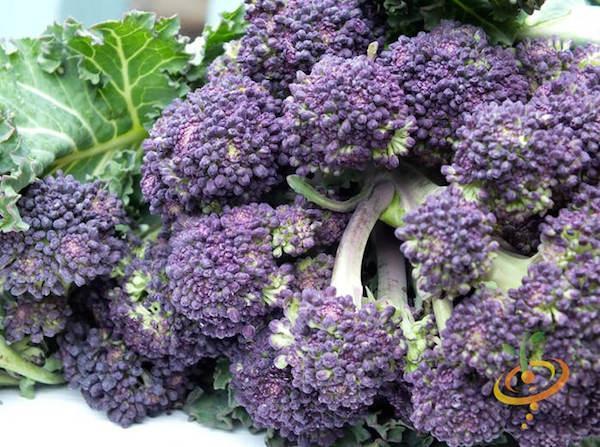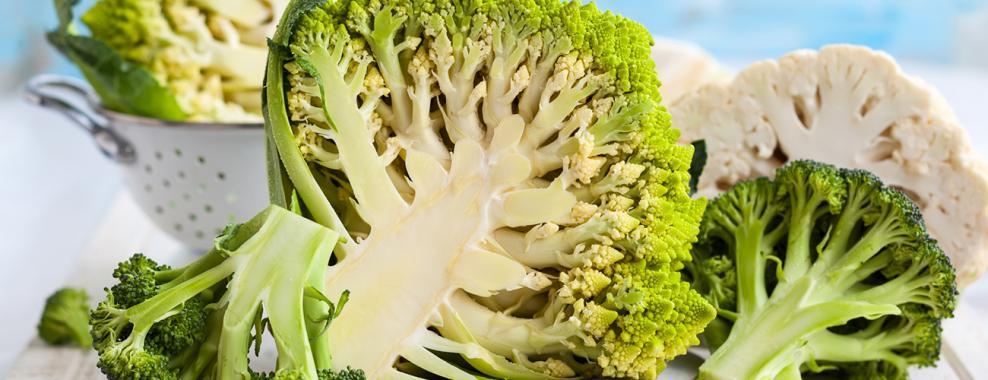The first image is the image on the left, the second image is the image on the right. Assess this claim about the two images: "One photo shows vegetables lying on a rough wooden surface.". Correct or not? Answer yes or no. No. The first image is the image on the left, the second image is the image on the right. Considering the images on both sides, is "One of the vegetables has purple colored sprouts." valid? Answer yes or no. Yes. 